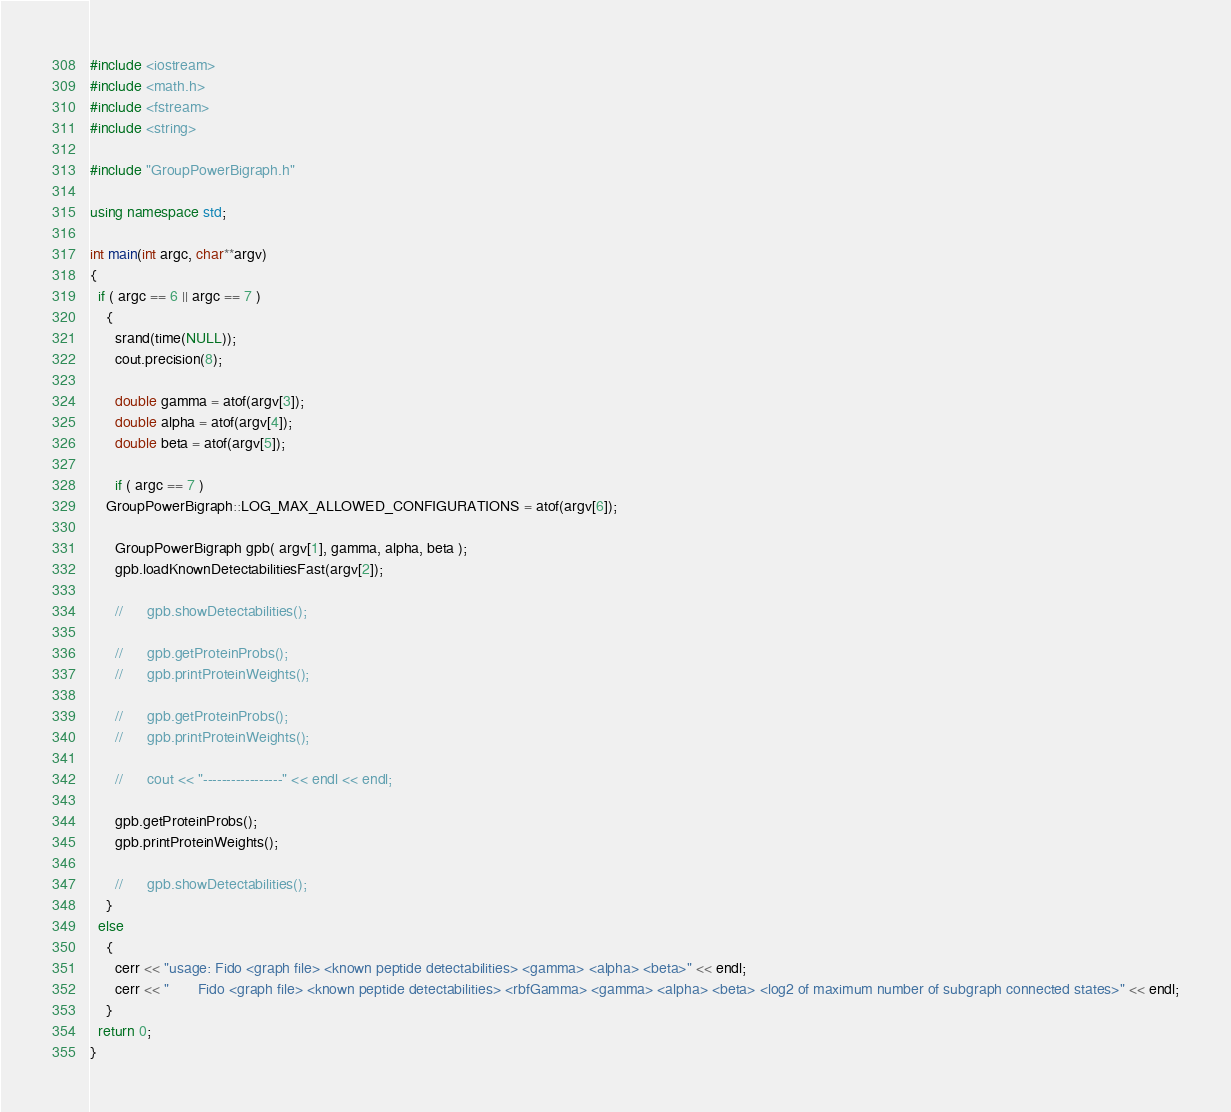Convert code to text. <code><loc_0><loc_0><loc_500><loc_500><_C++_>#include <iostream>
#include <math.h>
#include <fstream>
#include <string>

#include "GroupPowerBigraph.h"

using namespace std;

int main(int argc, char**argv)
{
  if ( argc == 6 || argc == 7 )
    {
      srand(time(NULL));
      cout.precision(8);

      double gamma = atof(argv[3]);
      double alpha = atof(argv[4]);
      double beta = atof(argv[5]);

      if ( argc == 7 )
	GroupPowerBigraph::LOG_MAX_ALLOWED_CONFIGURATIONS = atof(argv[6]);

      GroupPowerBigraph gpb( argv[1], gamma, alpha, beta );
      gpb.loadKnownDetectabilitiesFast(argv[2]);

      //      gpb.showDetectabilities();
      
      //      gpb.getProteinProbs();
      //      gpb.printProteinWeights();

      //      gpb.getProteinProbs();
      //      gpb.printProteinWeights();

      //      cout << "-----------------" << endl << endl;

      gpb.getProteinProbs();
      gpb.printProteinWeights();

      //      gpb.showDetectabilities();
    }
  else
    {
      cerr << "usage: Fido <graph file> <known peptide detectabilities> <gamma> <alpha> <beta>" << endl;
      cerr << "       Fido <graph file> <known peptide detectabilities> <rbfGamma> <gamma> <alpha> <beta> <log2 of maximum number of subgraph connected states>" << endl;
    }
  return 0;
}

</code> 